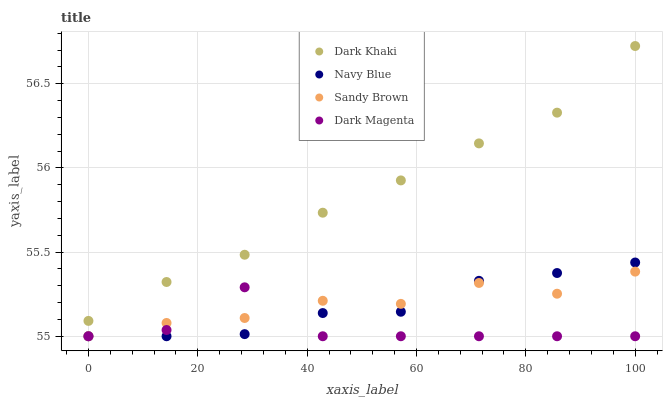Does Dark Magenta have the minimum area under the curve?
Answer yes or no. Yes. Does Dark Khaki have the maximum area under the curve?
Answer yes or no. Yes. Does Navy Blue have the minimum area under the curve?
Answer yes or no. No. Does Navy Blue have the maximum area under the curve?
Answer yes or no. No. Is Dark Khaki the smoothest?
Answer yes or no. Yes. Is Dark Magenta the roughest?
Answer yes or no. Yes. Is Navy Blue the smoothest?
Answer yes or no. No. Is Navy Blue the roughest?
Answer yes or no. No. Does Navy Blue have the lowest value?
Answer yes or no. Yes. Does Dark Khaki have the highest value?
Answer yes or no. Yes. Does Navy Blue have the highest value?
Answer yes or no. No. Is Sandy Brown less than Dark Khaki?
Answer yes or no. Yes. Is Dark Khaki greater than Dark Magenta?
Answer yes or no. Yes. Does Dark Magenta intersect Sandy Brown?
Answer yes or no. Yes. Is Dark Magenta less than Sandy Brown?
Answer yes or no. No. Is Dark Magenta greater than Sandy Brown?
Answer yes or no. No. Does Sandy Brown intersect Dark Khaki?
Answer yes or no. No. 